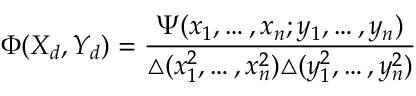<formula> <loc_0><loc_0><loc_500><loc_500>\Phi ( X _ { d } , Y _ { d } ) = \frac { \Psi ( x _ { 1 } , \dots , x _ { n } ; y _ { 1 } , \dots , y _ { n } ) } { \triangle ( x _ { 1 } ^ { 2 } , \dots , x _ { n } ^ { 2 } ) \triangle ( y _ { 1 } ^ { 2 } , \dots , y _ { n } ^ { 2 } ) }</formula> 